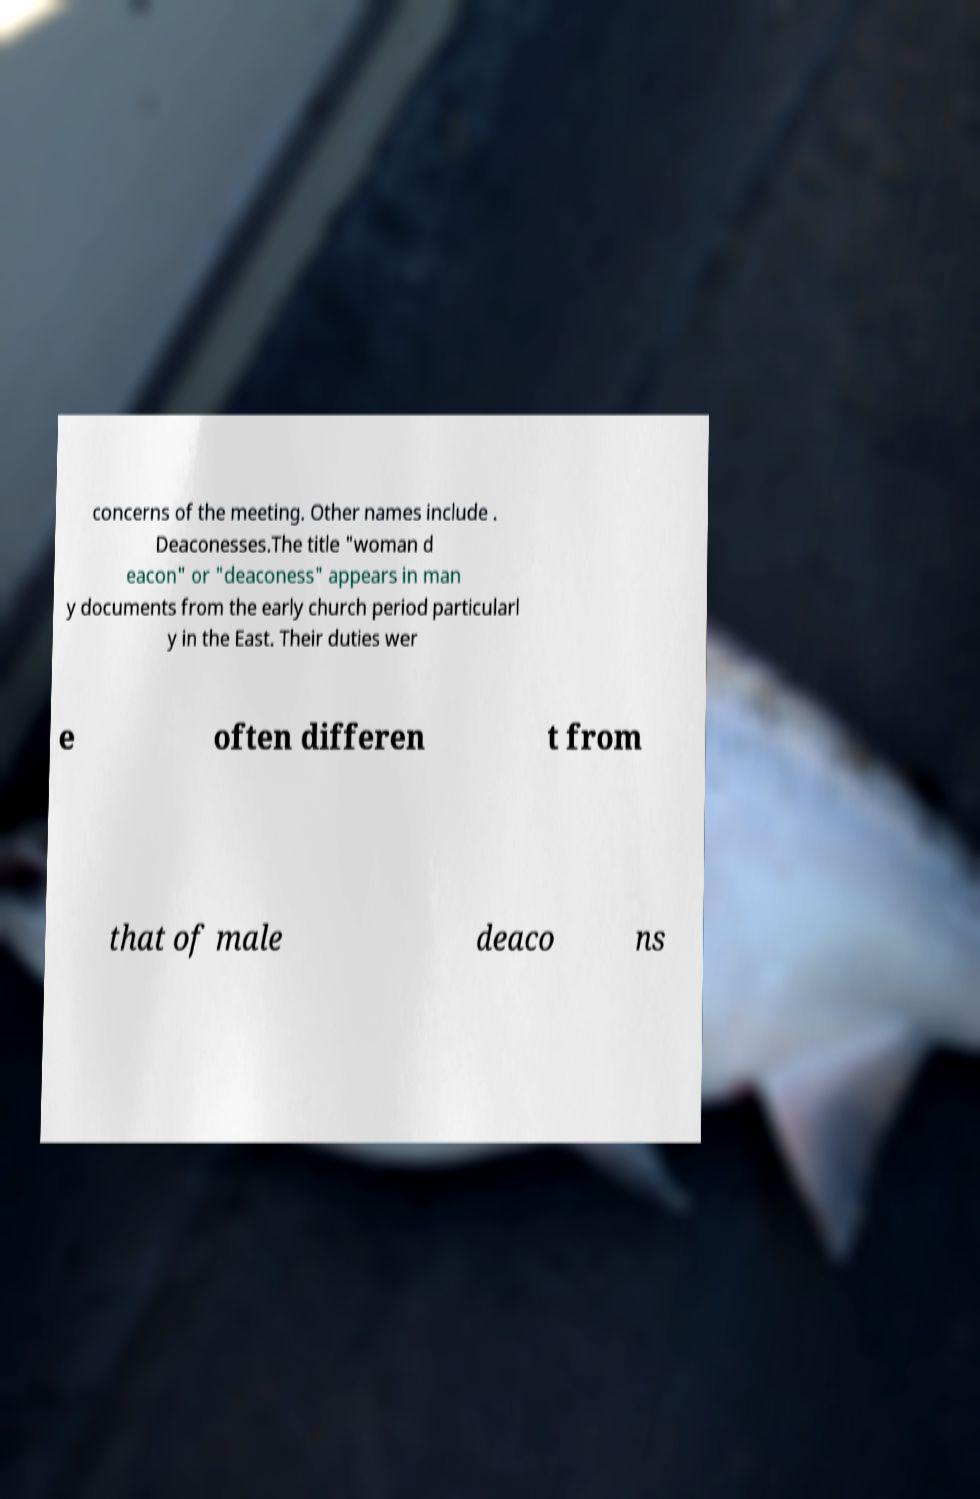What messages or text are displayed in this image? I need them in a readable, typed format. concerns of the meeting. Other names include . Deaconesses.The title "woman d eacon" or "deaconess" appears in man y documents from the early church period particularl y in the East. Their duties wer e often differen t from that of male deaco ns 